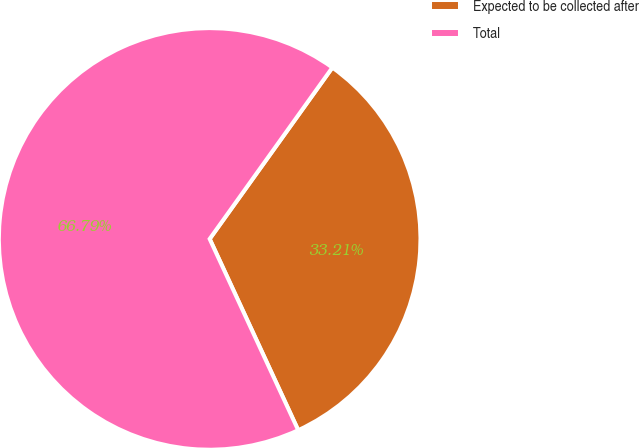Convert chart. <chart><loc_0><loc_0><loc_500><loc_500><pie_chart><fcel>Expected to be collected after<fcel>Total<nl><fcel>33.21%<fcel>66.79%<nl></chart> 